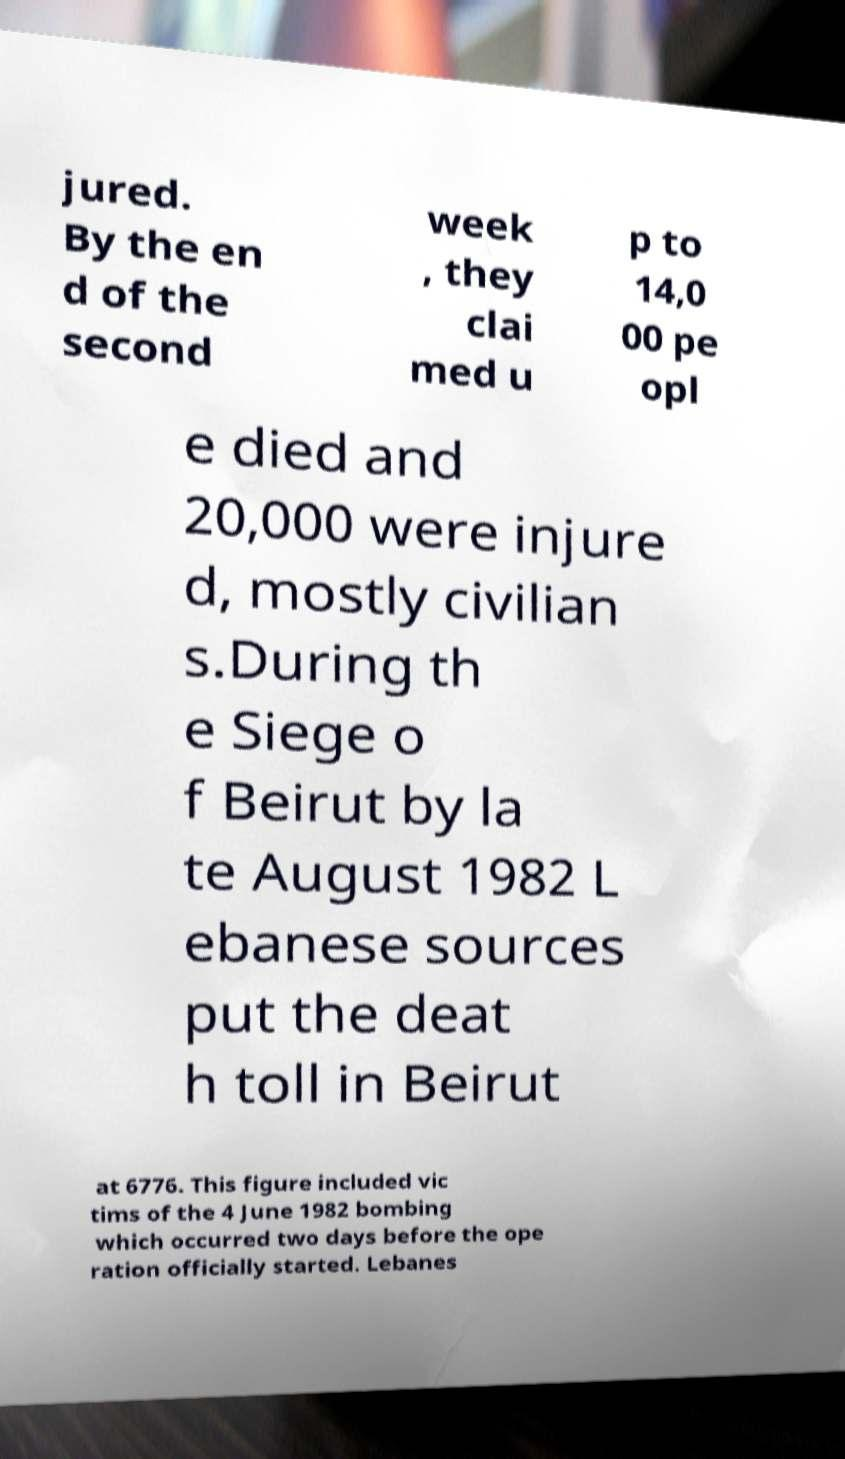Can you read and provide the text displayed in the image?This photo seems to have some interesting text. Can you extract and type it out for me? jured. By the en d of the second week , they clai med u p to 14,0 00 pe opl e died and 20,000 were injure d, mostly civilian s.During th e Siege o f Beirut by la te August 1982 L ebanese sources put the deat h toll in Beirut at 6776. This figure included vic tims of the 4 June 1982 bombing which occurred two days before the ope ration officially started. Lebanes 